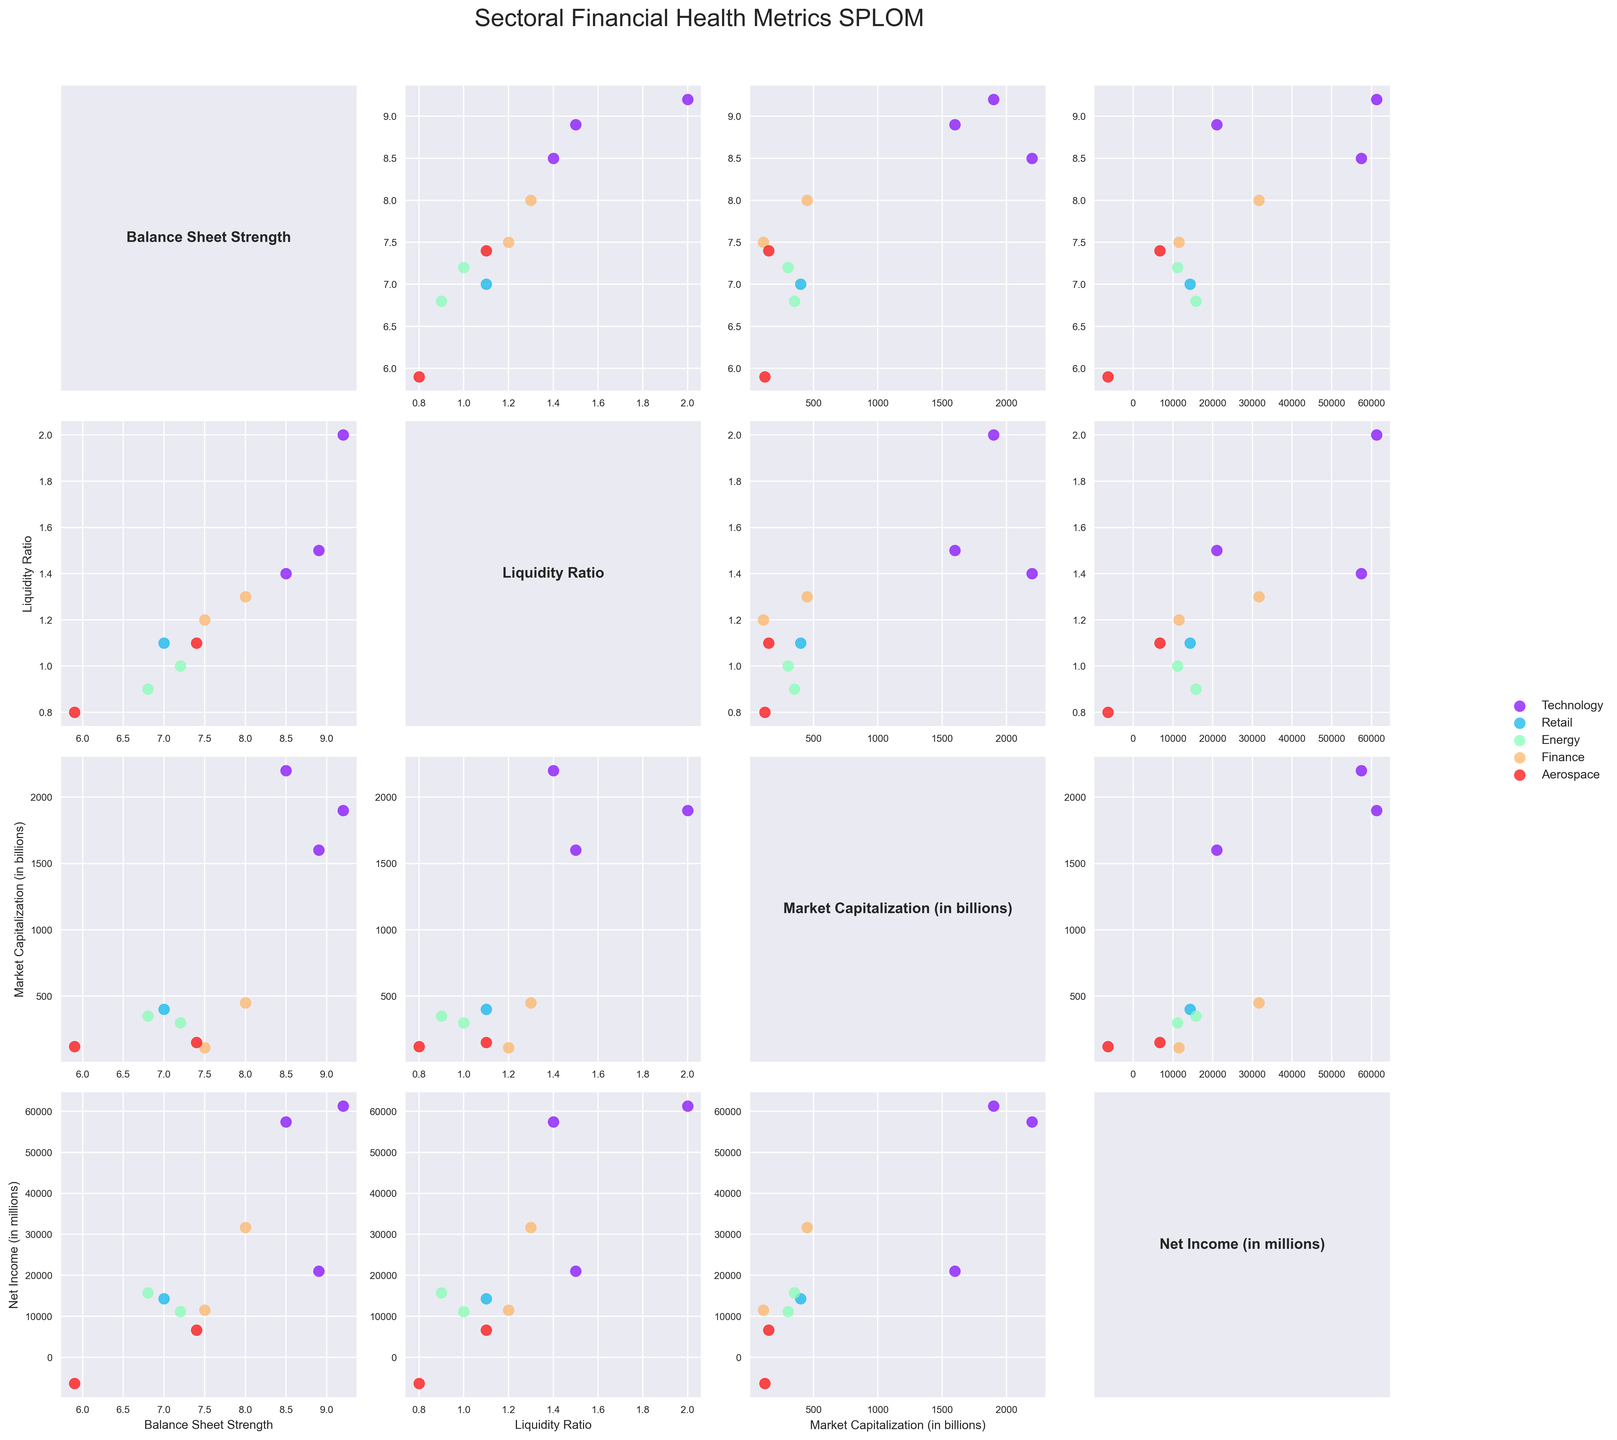How many sectors are represented in the SPLOM? The different colors in the scatter plot matrix correspond to different sectors. We can count the unique colors in the legend to determine the number of sectors.
Answer: 4 Which sector shows the highest value in the Balance Sheet Strength dimension? By observing the intersection of 'Balance Sheet Strength' with itself, we can identify the maximum value point. The color indicates the sector.
Answer: Technology How does the Net Income of Technology companies compare to other sectors? By looking at the 'Net Income' row for Technology (identified by color), we can compare the range of Net Income values with other sectors in the same row.
Answer: Generally higher What's the relationship between Market Capitalization and Liquidity Ratio for Boeing? Locate Boeing in the 'Market Capitalization' vs 'Liquidity Ratio' scatter plot by its color and observe the position of the data point.
Answer: Boeing has low Market Capitalization and low Liquidity Ratio Which two sectors have overlapping values in the Balance Sheet Strength vs Net Income scatter plot? By observing the 'Balance Sheet Strength' vs 'Net Income' plot, we can see where different sector colors have overlapping data points.
Answer: Finance and Technology Is there a sector with consistently low values in Balance Sheet Strength across all plots? We need to look at all the Balance Sheet Strength columns for consistent low values and identify the sector color.
Answer: Aerospace Among the Retail and Energy sectors, which has better Liquidity Ratio? Compare the data points of Retail (green) and Energy (yellow) in the 'Liquidity Ratio' dimension.
Answer: Retail Which sector occupies the largest range in Market Capitalization and Net Income simultaneously? Look at the 'Market Capitalization' and 'Net Income' rows and compare the spread of values for each sector.
Answer: Technology Does any company in the Aerospace sector exhibit negative Net Income? Identify the Aerospace sector in the 'Net Income' column and check for negative value data points.
Answer: Yes What can you infer about the relation between Balance Sheet Strength and Market Capitalization within the Technology sector? Locate the 'Balance Sheet Strength' vs 'Market Capitalization' plot for Technology and observe the pattern of data points.
Answer: Positive correlation 